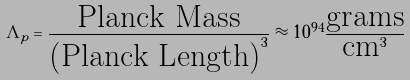<formula> <loc_0><loc_0><loc_500><loc_500>\Lambda _ { p } = \frac { \text {Planck Mass} } { \text {(Planck Length)} ^ { 3 } } \approx 1 0 ^ { 9 4 } \frac { \text {grams} } { \text {cm} ^ { 3 } }</formula> 